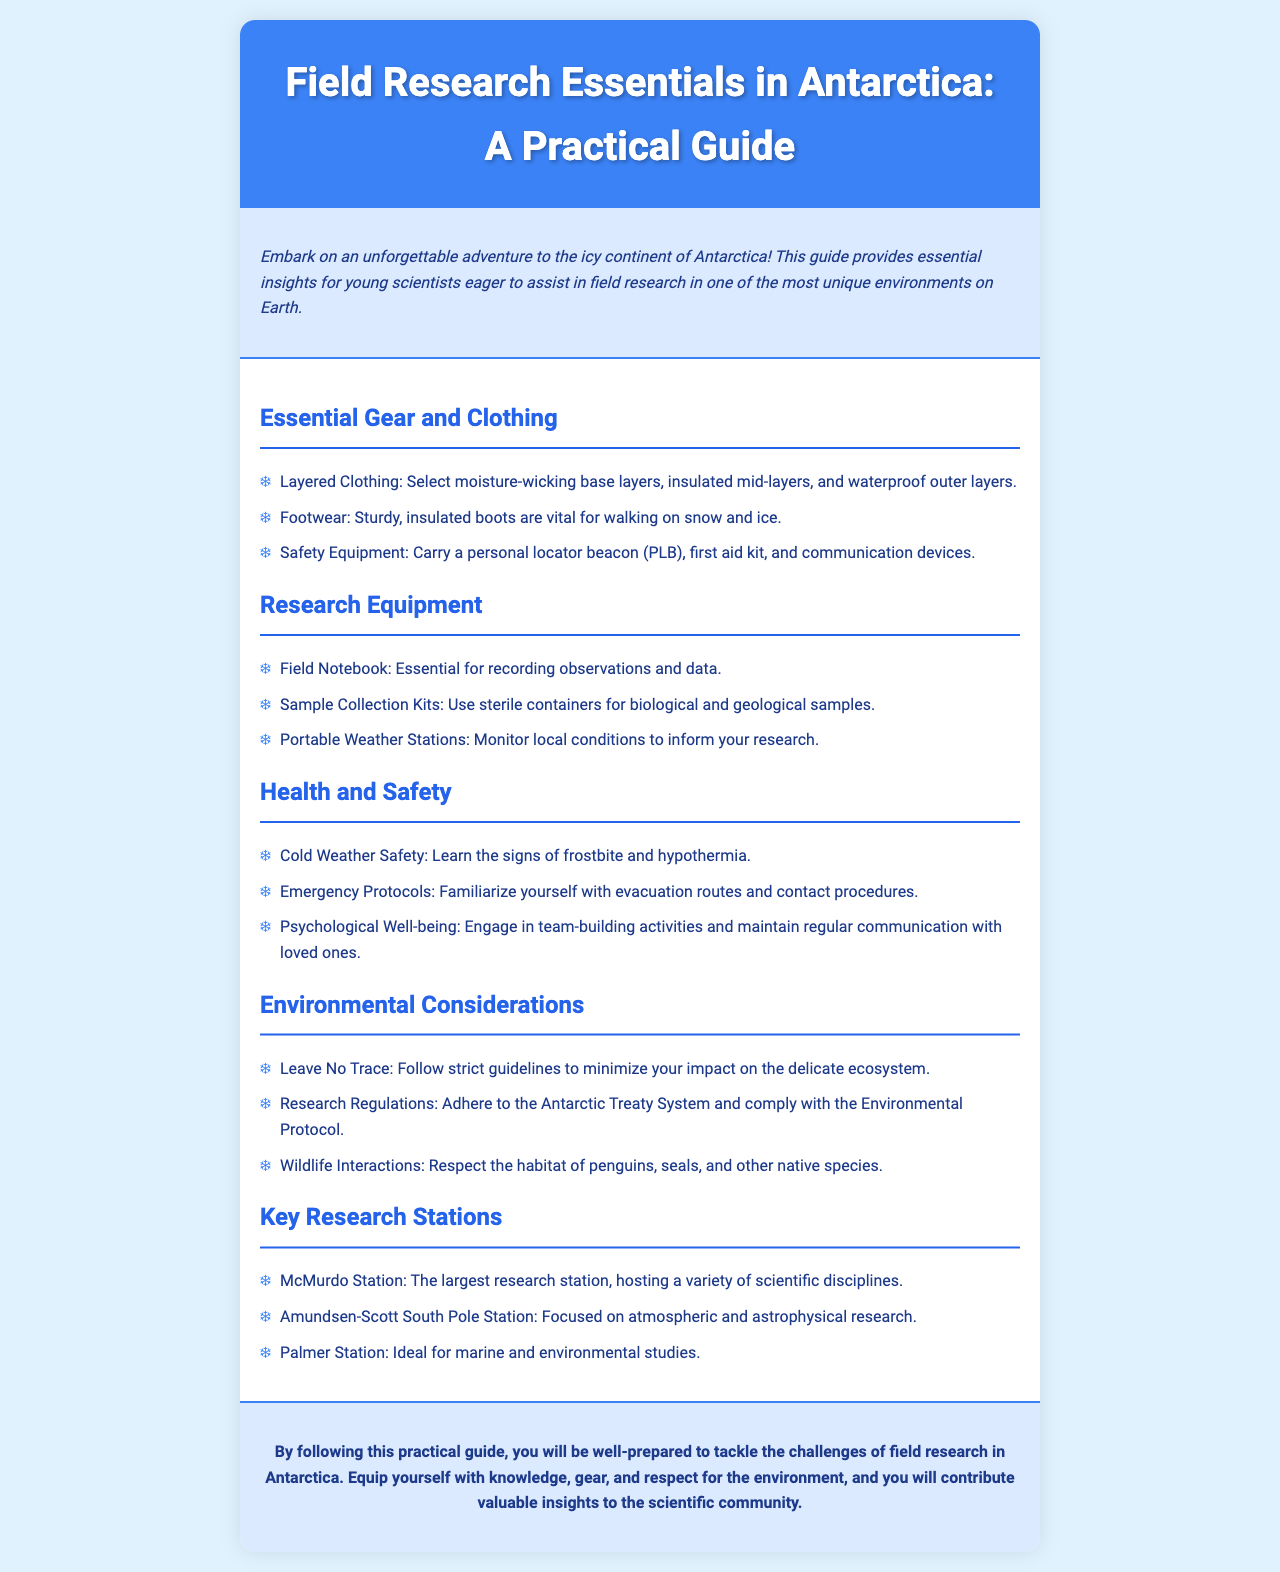what is the title of the guide? The title of the guide is prominently displayed in the header section of the document.
Answer: Field Research Essentials in Antarctica: A Practical Guide what type of footwear is vital for walking on snow and ice? The guide specifies the necessary type of footwear listed under essential gear.
Answer: Sturdy, insulated boots name one type of equipment essential for recording observations. The document lists specific research equipment needed for field research.
Answer: Field Notebook what should you learn about for cold weather safety? The guide outlines health and safety guidance including key aspects to understand in cold environments.
Answer: Signs of frostbite and hypothermia which research station focuses on atmospheric and astrophysical research? This question asks for the name of a specific research station mentioned in the document's key research stations section.
Answer: Amundsen-Scott South Pole Station what environmental principle should researchers follow? The guide emphasizes responsible practices to minimize environmental impact.
Answer: Leave No Trace what is one way to maintain psychological well-being? The document provides suggestions for ensuring team members' mental health during field research.
Answer: Engage in team-building activities how many key research stations are listed in the document? The document contains a specific number of research stations that are mentioned as key locations for research.
Answer: Three 